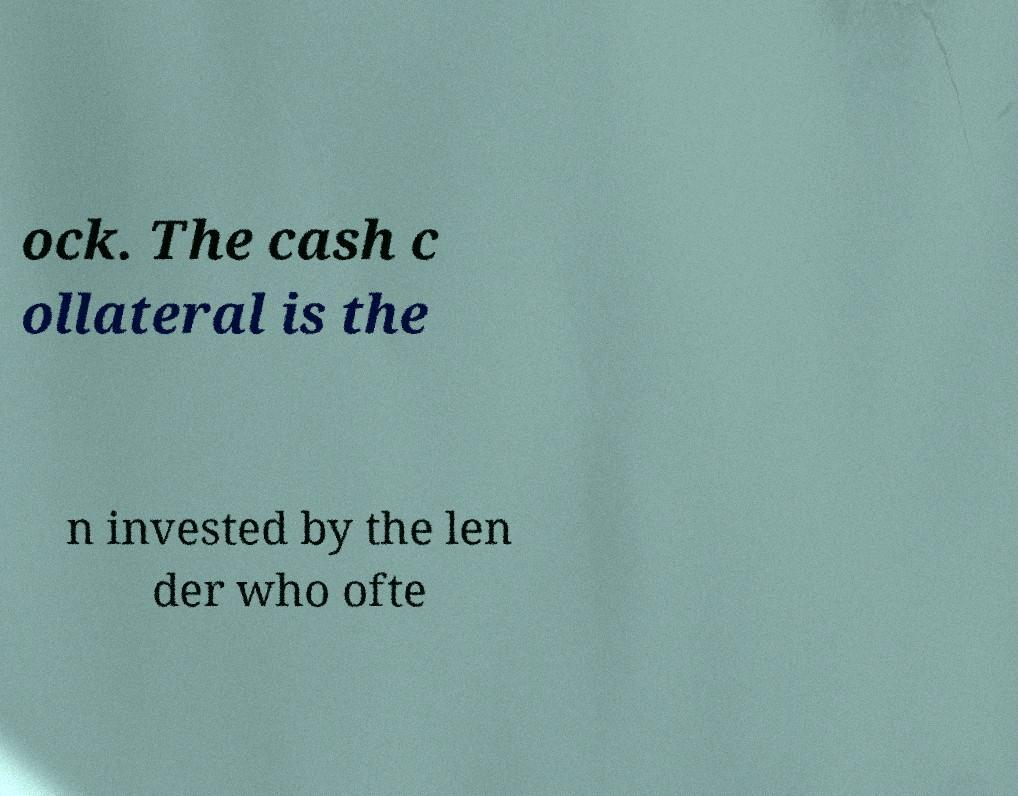Can you read and provide the text displayed in the image?This photo seems to have some interesting text. Can you extract and type it out for me? ock. The cash c ollateral is the n invested by the len der who ofte 